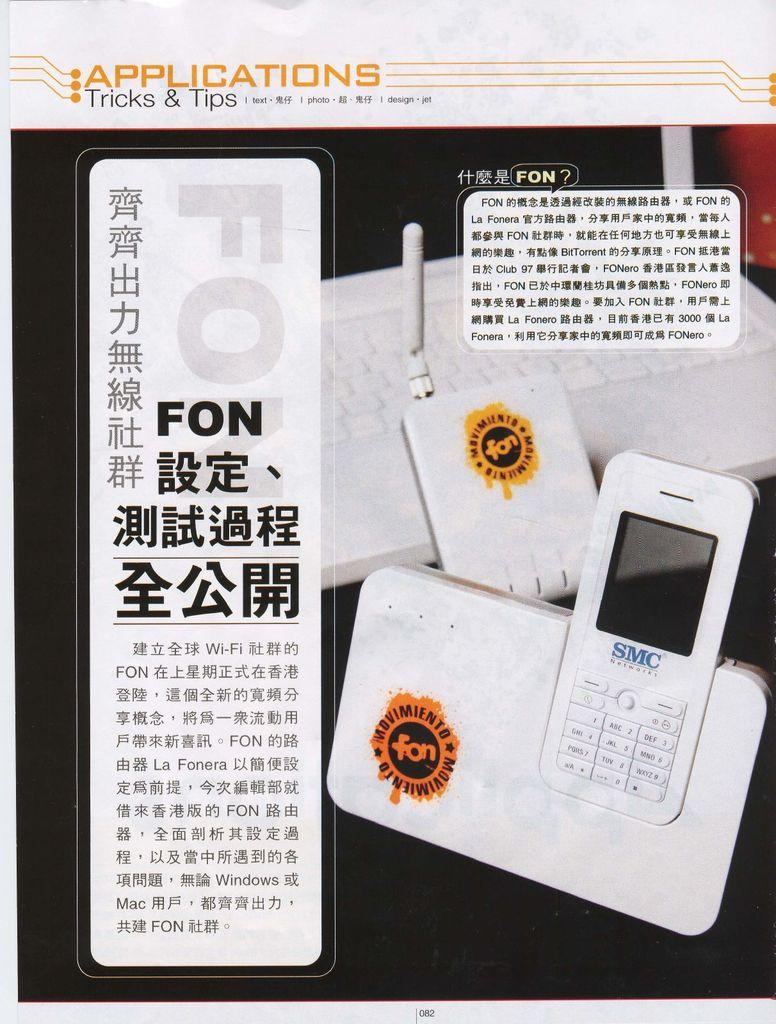What brand of phone is this?
Provide a short and direct response. Smc. 